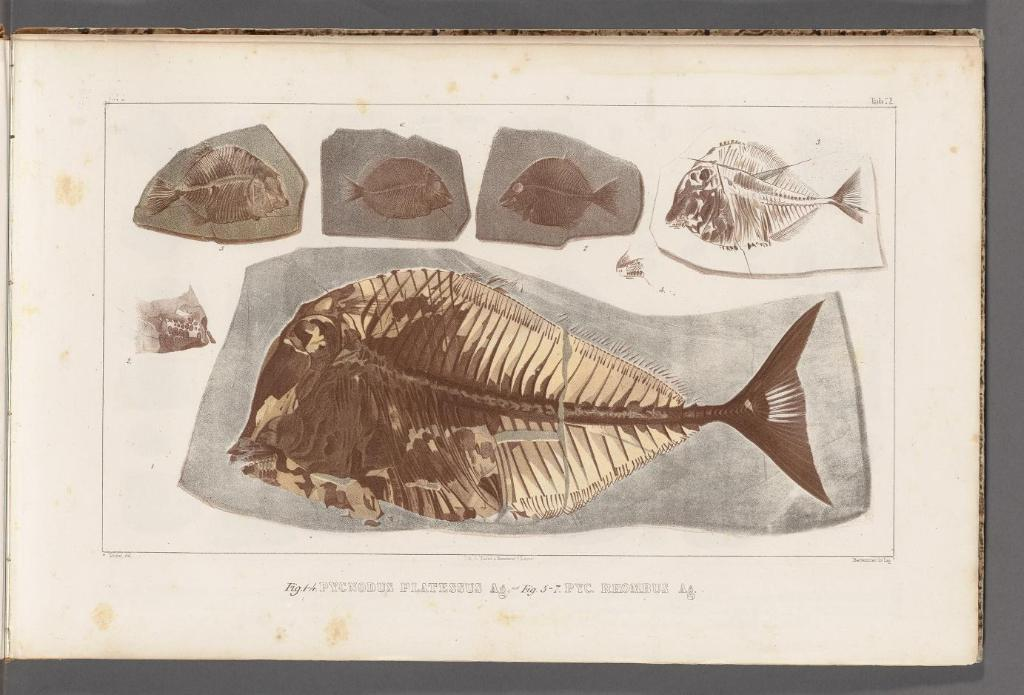What is depicted on the paper in the image? The paper contains images of fish. Are there any words or letters on the paper? Yes, there is text on the paper. What color is the background of the image? The background color of the image is gray. Can you tell me how many men are combing their hair in the image? There are no men or combs present in the image; it features a paper with images of fish and text. 